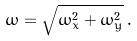<formula> <loc_0><loc_0><loc_500><loc_500>\omega = \sqrt { \omega ^ { 2 } _ { x } + \omega _ { y } ^ { 2 } } \, .</formula> 